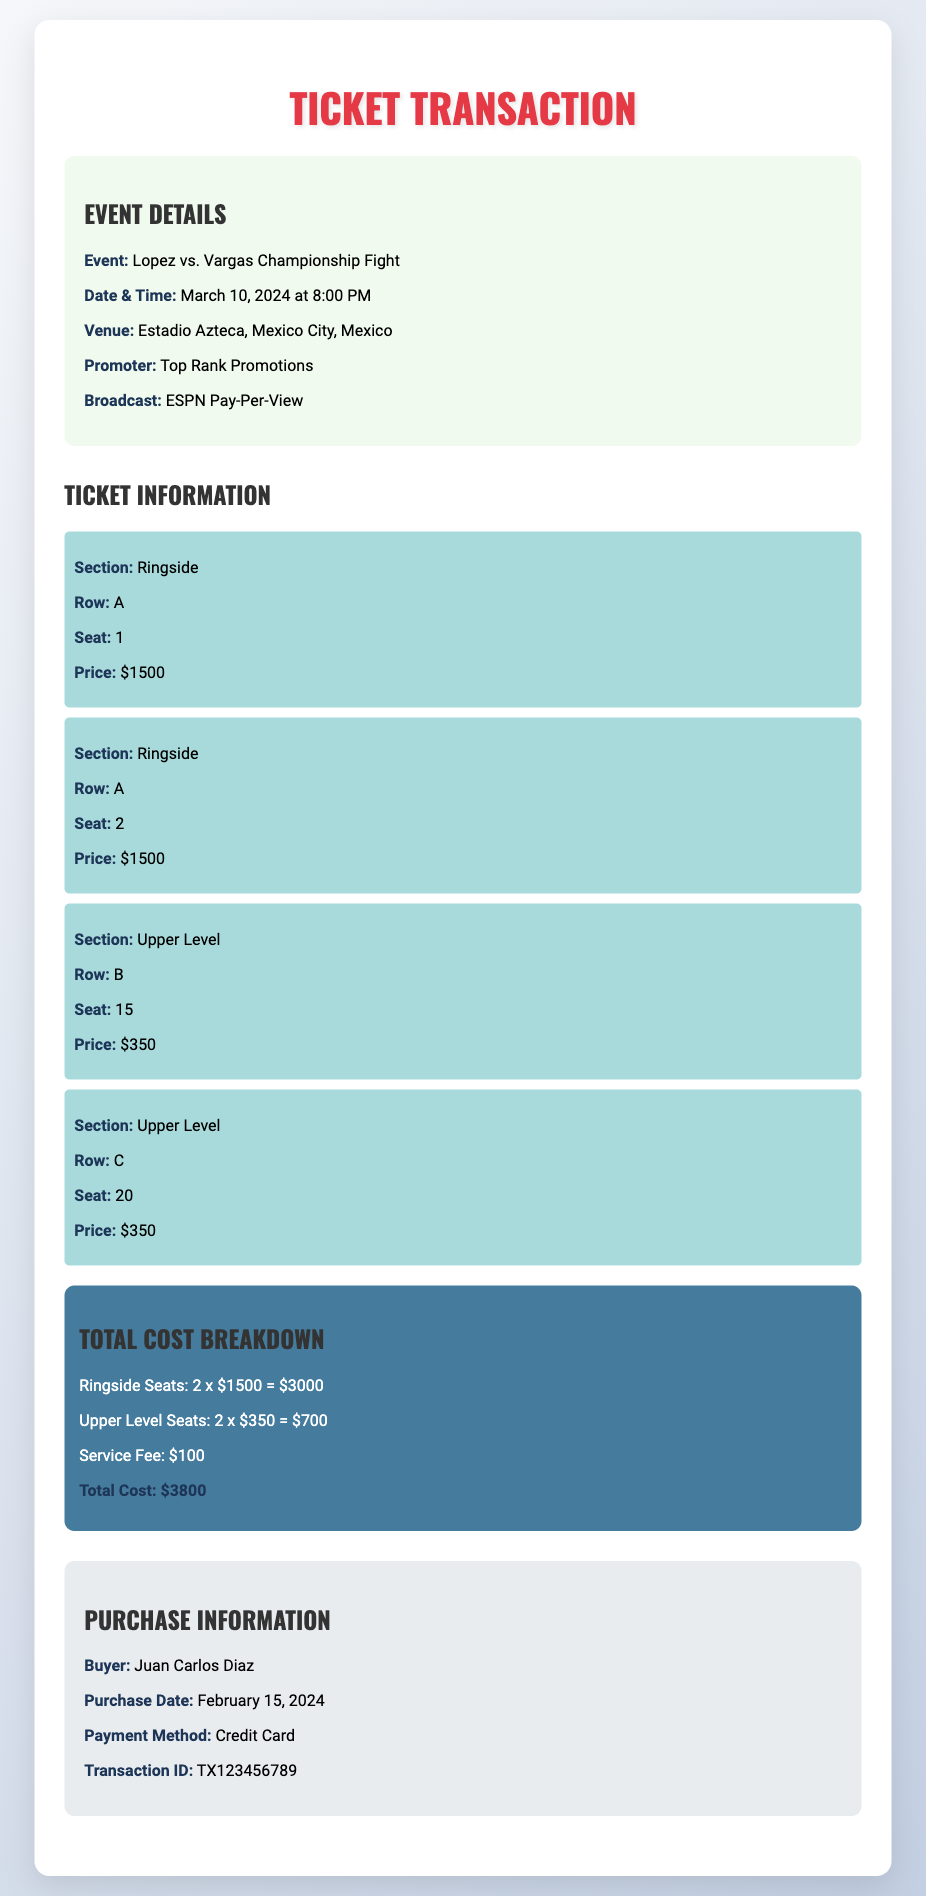What is the event name? The event name is clearly stated in the document.
Answer: Lopez vs. Vargas Championship Fight When is the fight scheduled? The date and time of the event are mentioned in the event details section.
Answer: March 10, 2024 at 8:00 PM Where is the venue located? The venue location is provided, indicating where the event will take place.
Answer: Estadio Azteca, Mexico City, Mexico How much is the total cost of the tickets? The total cost breakdown section sums all ticket prices and fees.
Answer: $3800 What payment method was used for the purchase? The document specifies the payment method in the purchase information section.
Answer: Credit Card How many ringside seats were purchased? The ticket information section reveals the count of ringside seats selected.
Answer: 2 What is the transaction ID? The document contains a unique identifier for the transaction in the purchase info.
Answer: TX123456789 What is the service fee? The total cost breakdown includes a line for the service fee, highlighting its value.
Answer: $100 How many seats are located in the upper level? The document mentions specific upper level seats in the ticket information section.
Answer: 2 